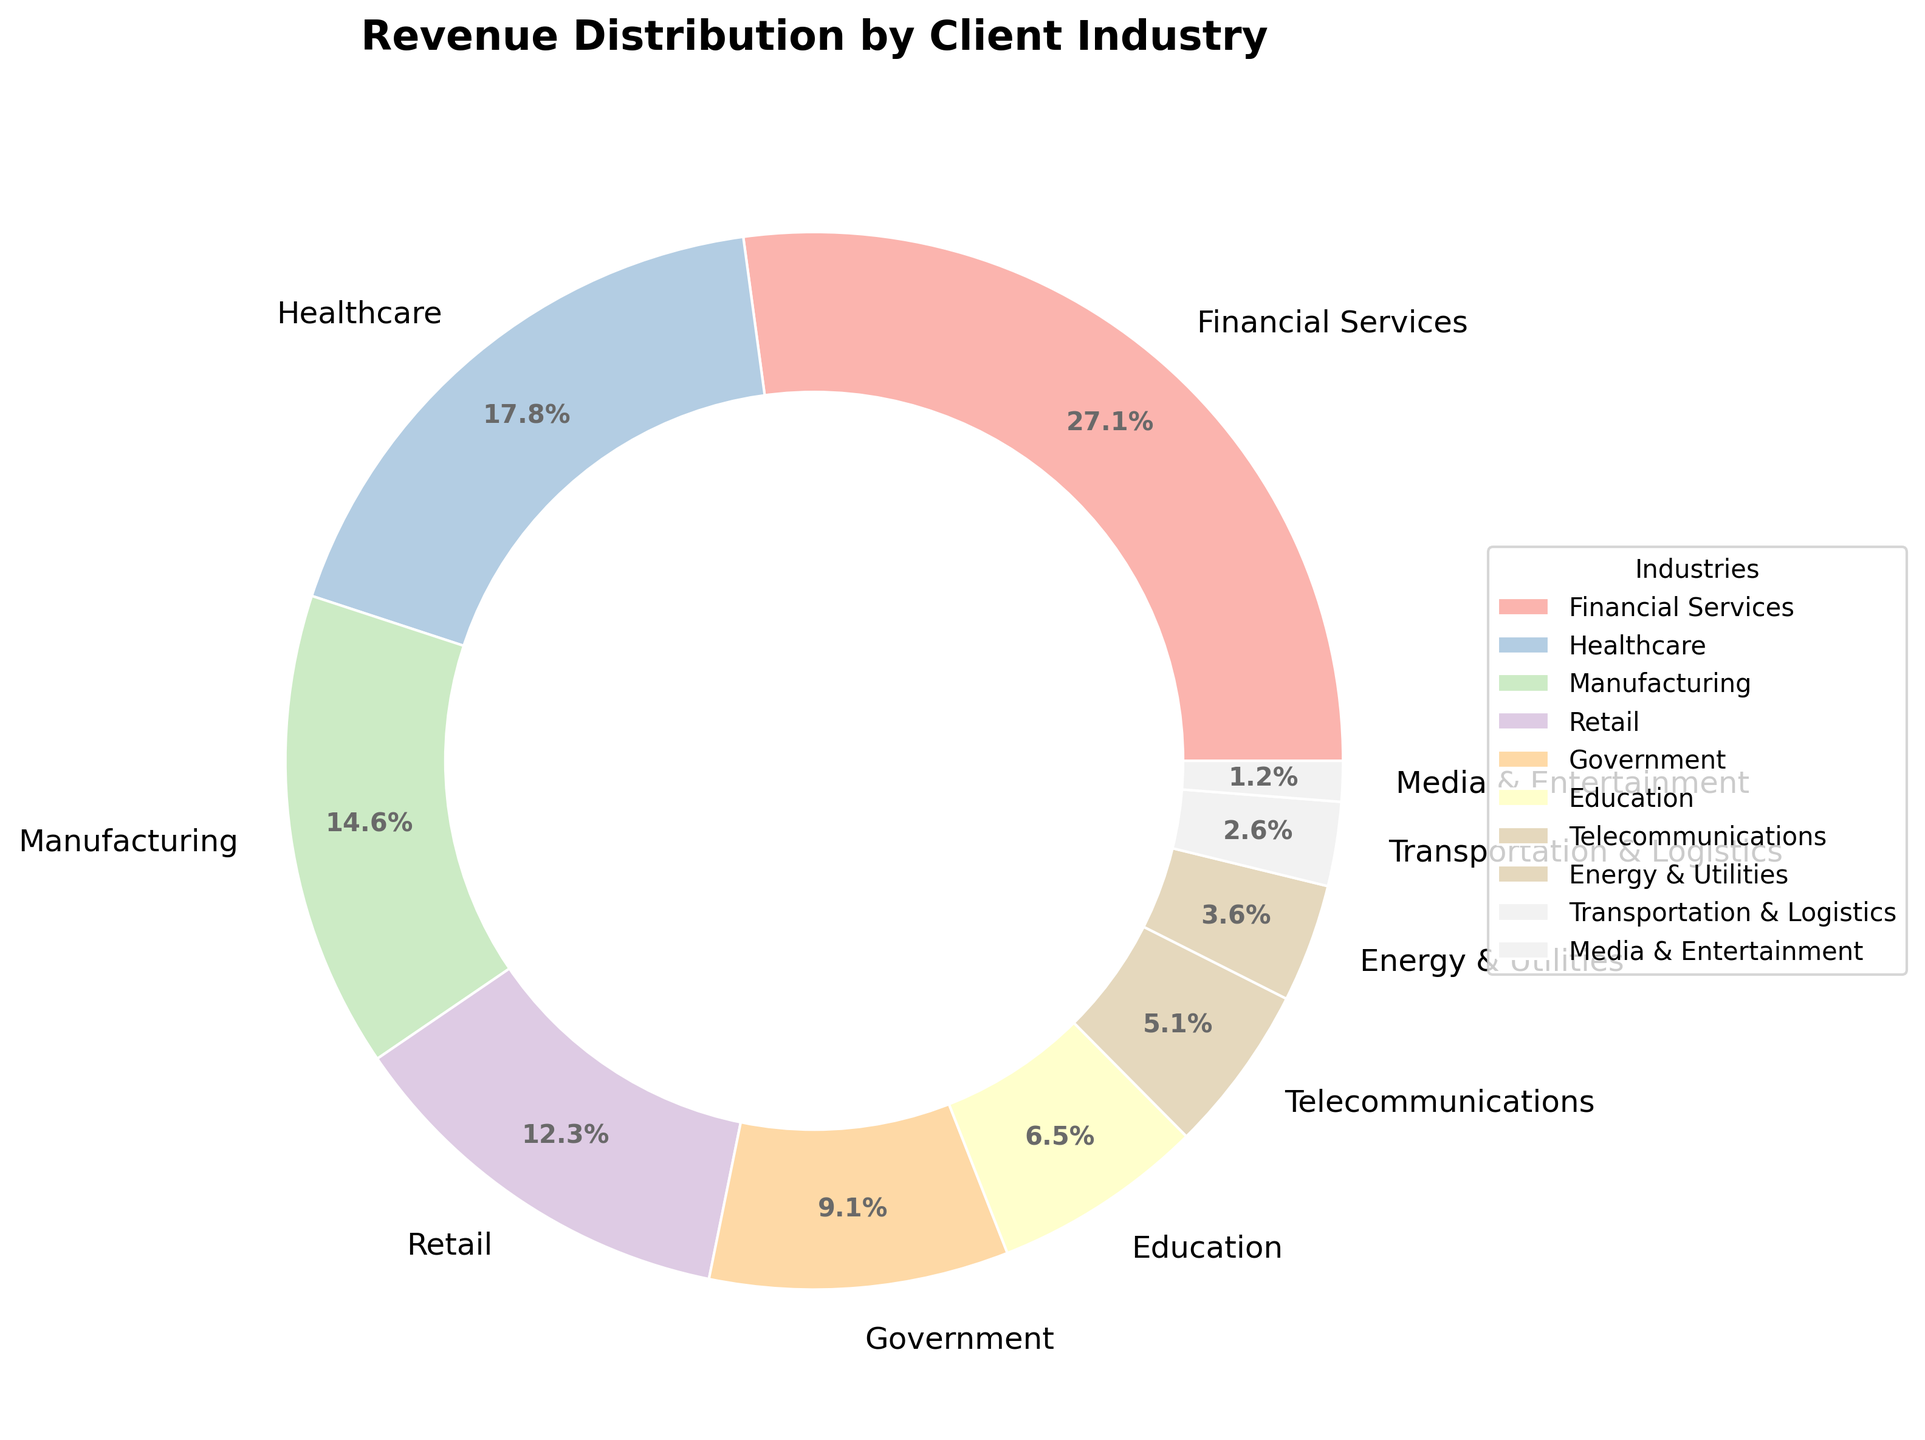Which industry accounts for the highest revenue percentage? The industry with the largest segment in the pie chart is Financial Services. The label shows it accounts for 28.5% of the revenue.
Answer: Financial Services What's the combined revenue percentage for the Retail and Government industries? From the pie chart, the revenue percentage for Retail is 12.9% and for Government is 9.6%. Combined, it is 12.9% + 9.6% = 22.5%.
Answer: 22.5% Which industry contributes the least to the revenue? The smallest segment in the pie chart corresponds to Media & Entertainment, which contributes 1.3%.
Answer: Media & Entertainment Is the percentage revenue from Healthcare higher than from Manufacturing? The pie chart shows Healthcare at 18.7% and Manufacturing at 15.3%. Hence, Healthcare is higher than Manufacturing.
Answer: Yes What is the difference in revenue percentage between Financial Services and Education? Financial Services is at 28.5% and Education is at 6.8%. The difference is 28.5% - 6.8% = 21.7%.
Answer: 21.7% What is the total revenue percentage of industries contributing less than 10% each? The industries contributing less than 10% each are Government (9.6%), Education (6.8%), Telecommunications (5.4%), Energy & Utilities (3.8%), Transportation & Logistics (2.7%), and Media & Entertainment (1.3%). Their total is 9.6% + 6.8% + 5.4% + 3.8% + 2.7% + 1.3% = 29.6%.
Answer: 29.6% How much higher in percentage is Healthcare compared to Telecommunications? Healthcare is at 18.7% while Telecommunications is at 5.4%. The difference is 18.7% - 5.4% = 13.3%.
Answer: 13.3% Does Manufacturing or Retail have a larger revenue percentage? The pie chart shows Manufacturing at 15.3% and Retail at 12.9%. Manufacturing is larger than Retail.
Answer: Manufacturing Which industry has just below 5% of the revenue percentage? The segment just below 5% in the pie chart is Energy & Utilities with 3.8%.
Answer: Energy & Utilities 